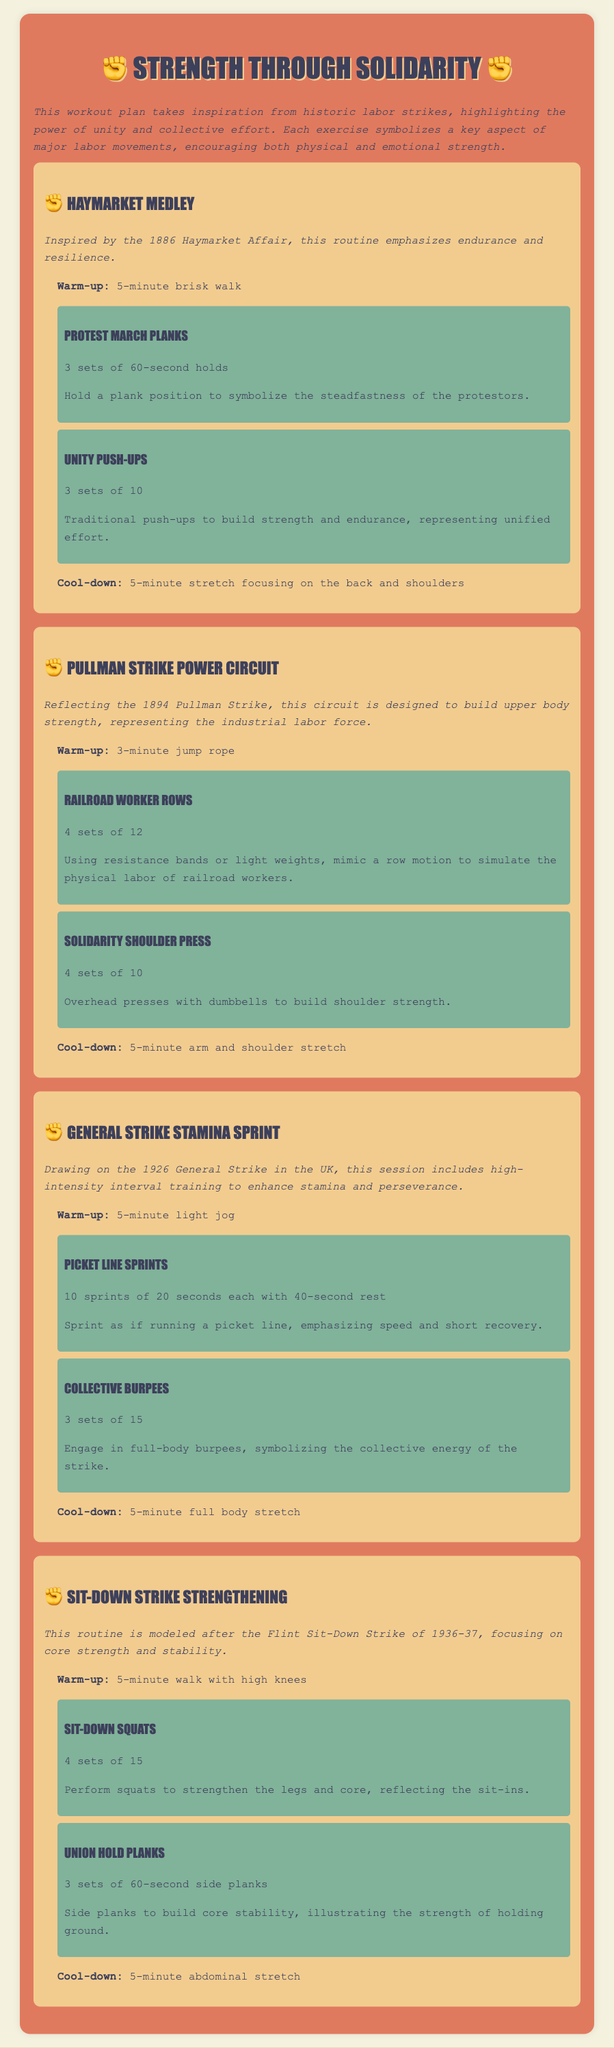what is the title of the workout plan? The title is prominently displayed at the top of the document.
Answer: Strength Through Solidarity which historic event inspires the Haymarket Medley? The description mentions a specific historical context that inspired this routine.
Answer: 1886 Haymarket Affair how many sets of Unity Push-ups are recommended? The number of sets for Unity Push-ups is specified in the exercise details.
Answer: 3 sets what is the focus of the General Strike Stamina Sprint session? The session's focus is indicated in the description following the title.
Answer: stamina and perseverance how many sprints are included in the Picket Line Sprints? The number of sprints is outlined in the details of the exercise.
Answer: 10 sprints what type of stretching is recommended after the Sit-Down Strike Strengthening routine? The cool-down type is clearly stated in the section about Sit-Down Strike Strengthening.
Answer: abdominal stretch which exercise reflects the physical labor of railroad workers? It can be found in the exercise section related to the Pullman Strike Power Circuit.
Answer: Railroad Worker Rows what exercise represents the collective energy of the strike? This is specified in the context of the General Strike Stamina Sprint.
Answer: Collective Burpees which historic labor movement does the workout plan emphasize? The core theme of the workout plan is explained at the beginning.
Answer: labor movements 